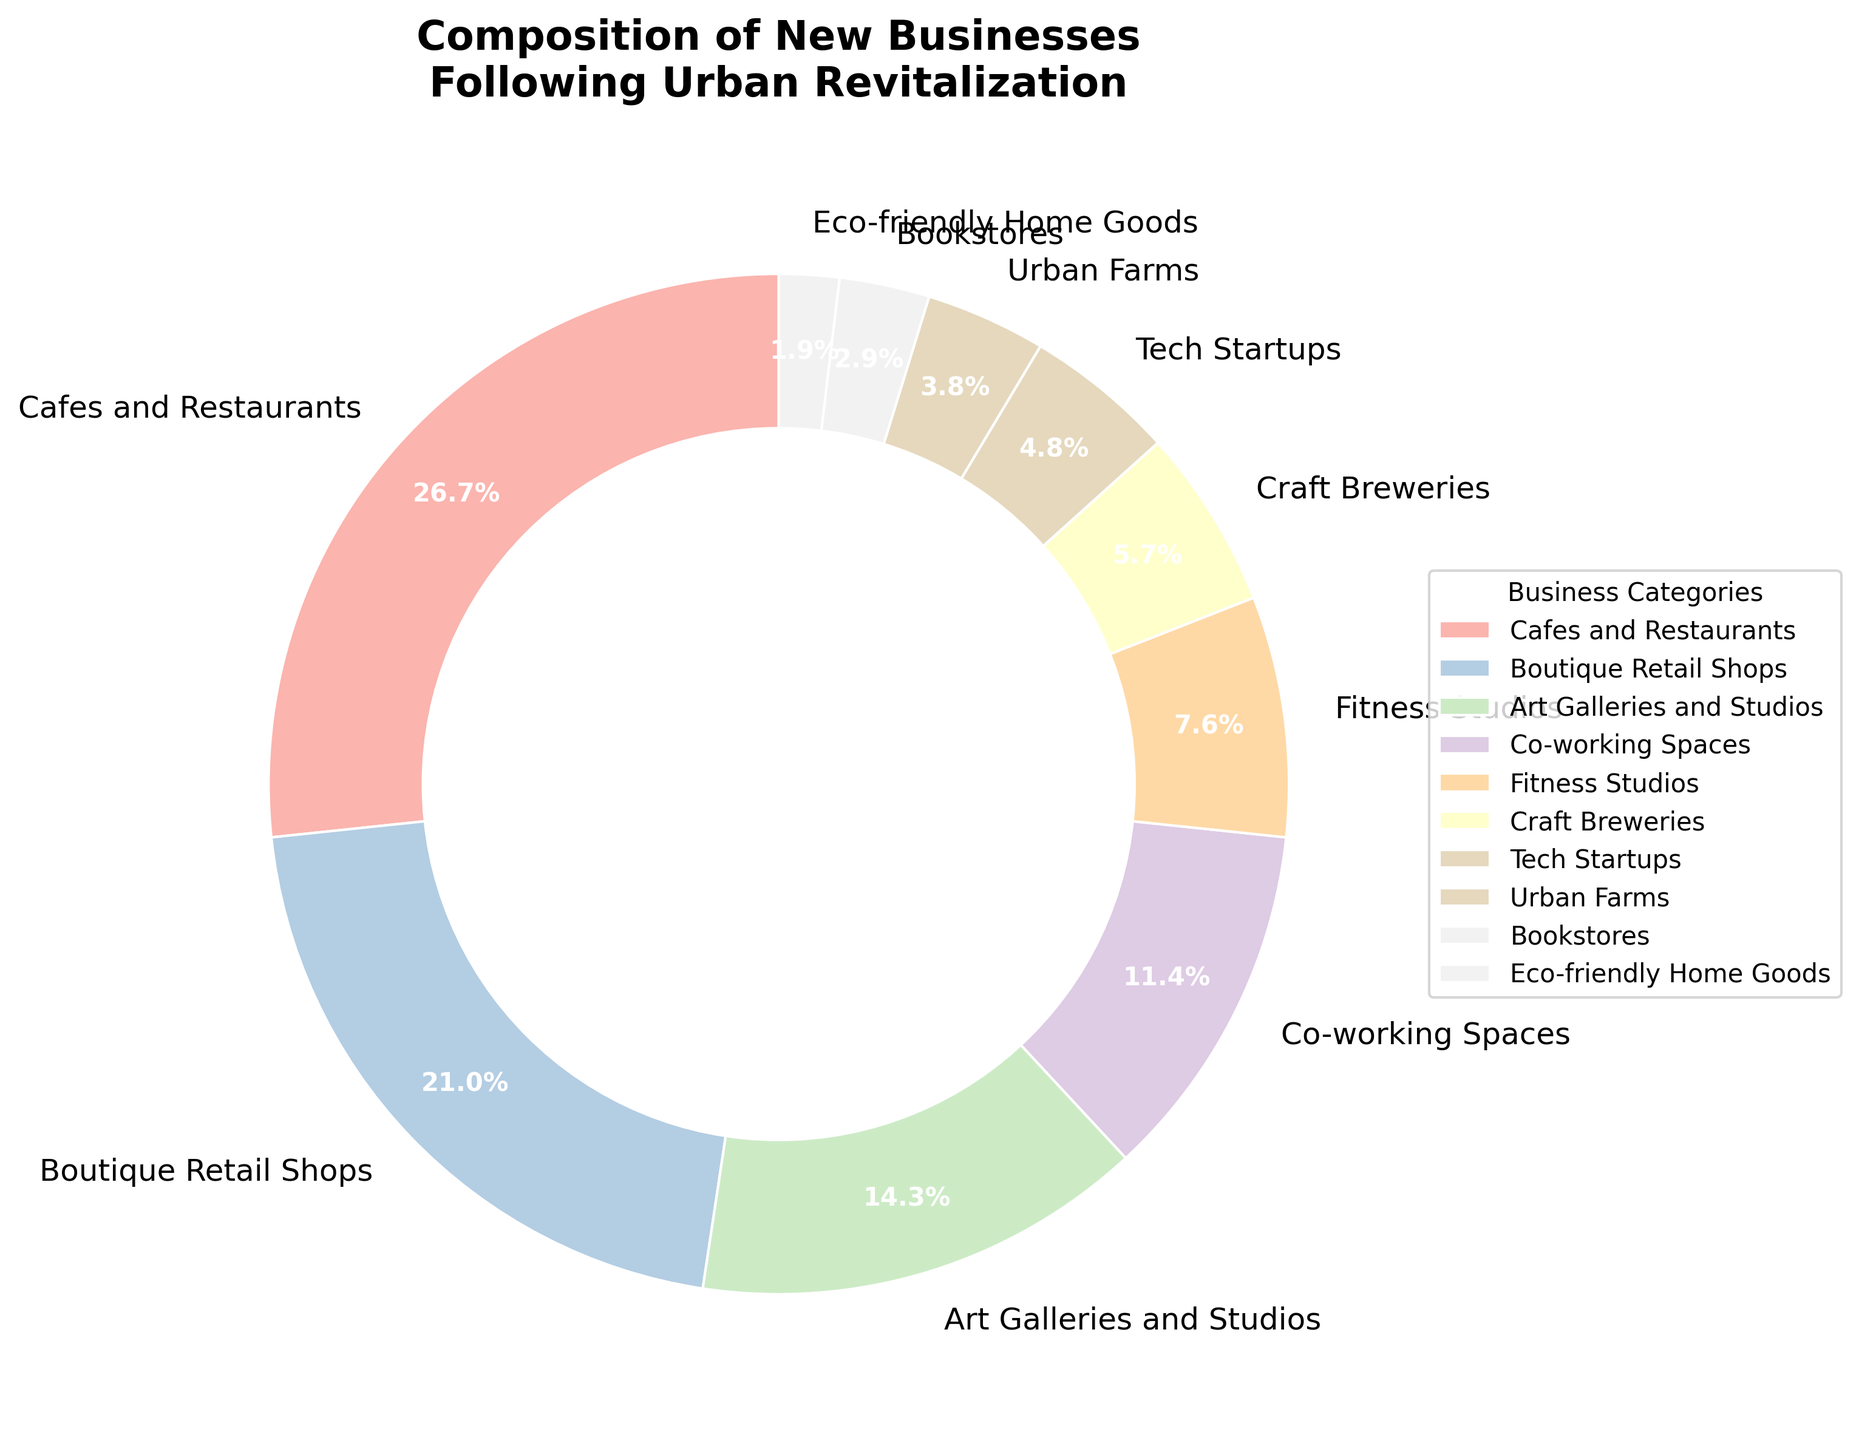What is the percentage of businesses that are cafes and restaurants? According to the pie chart, cafes and restaurants make up 28% of the new businesses that have opened following urban revitalization. This information is directly provided in the chart.
Answer: 28% Which category has a larger percentage, co-working spaces or tech startups? By looking at the pie chart, co-working spaces have 12% while tech startups have 5%. Comparing these values shows that co-working spaces have a larger percentage.
Answer: Co-working Spaces What is the total percentage of businesses made up by fitness studios and craft breweries combined? Adding the percentages of fitness studios (8%) and craft breweries (6%) gives us the combined total of these two categories: 8% + 6% = 14%.
Answer: 14% How many categories have a percentage of 10% or higher? From the pie chart, the categories with percentages 10% or higher are: Cafes and Restaurants (28%), Boutique Retail Shops (22%), Art Galleries and Studios (15%), and Co-working Spaces (12%). This totals to four categories.
Answer: 4 Which two categories combined have the same percentage as cafes and restaurants? Cafes and restaurants have 28%. By adding different category percentages: Boutique Retail Shops (22%) + Bookstores (3%) + Eco-friendly Home Goods (2%) = 27%, we see that no combination exactly matches 28%. The closest would be boutique retail shops and art galleries, totaling (22% + 15% = 37%) which exceeds cafes and restaurants' 28%. However, using the exact match would be urban farms (4%) with co-working spaces (12%) and fitness studios (8%), totaling to (12%+8%+4%=24%) which is below.
Answer: No Exact Match What is the smallest category and its percentage? The smallest category on the pie chart is eco-friendly home goods, which has a percentage of 2%.
Answer: Eco-friendly Home Goods, 2% How does the percentage of urban farms compare to the percentage of bookstores? The pie chart shows that urban farms have a percentage of 4%, while bookstores have 3%. Therefore, urban farms have a higher percentage than bookstores.
Answer: Urban Farms > Bookstores What is the combined percentage of the categories that make up less than 10% each? The categories under 10% are: Fitness Studios (8%), Craft Breweries (6%), Tech Startups (5%), Urban Farms (4%), Bookstores (3%), and Eco-friendly Home Goods (2%). Adding these gives 8% + 6% + 5% + 4% + 3% + 2% = 28%.
Answer: 28% Is there a significant visual difference in the slice size of art galleries and studios compared to fitness studios? Based on the pie chart, art galleries and studios represent 15%, while fitness studios represent 8%. Visually, the slice for art galleries and studios is almost twice the size of the slice for fitness studios, indicating a significant visual difference in size.
Answer: Yes Which category has a slice that starts at the 12 o'clock position and moves clockwise? In most pie charts, the first slice usually begins at the 12 o'clock position and moves clockwise. In this chart, the first slice belongs to cafes and restaurants.
Answer: Cafes and Restaurants 